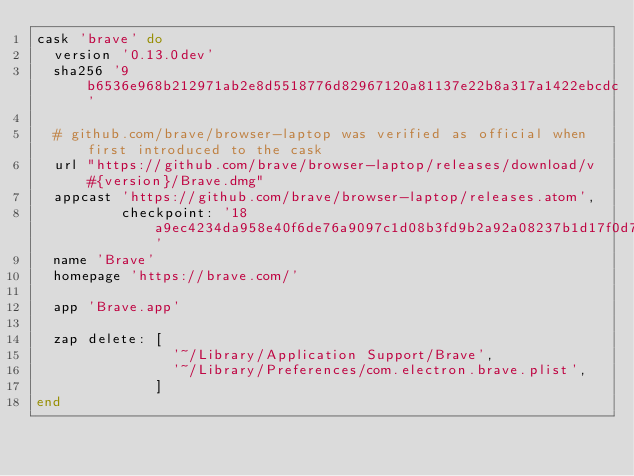<code> <loc_0><loc_0><loc_500><loc_500><_Ruby_>cask 'brave' do
  version '0.13.0dev'
  sha256 '9b6536e968b212971ab2e8d5518776d82967120a81137e22b8a317a1422ebcdc'

  # github.com/brave/browser-laptop was verified as official when first introduced to the cask
  url "https://github.com/brave/browser-laptop/releases/download/v#{version}/Brave.dmg"
  appcast 'https://github.com/brave/browser-laptop/releases.atom',
          checkpoint: '18a9ec4234da958e40f6de76a9097c1d08b3fd9b2a92a08237b1d17f0d7f489a'
  name 'Brave'
  homepage 'https://brave.com/'

  app 'Brave.app'

  zap delete: [
                '~/Library/Application Support/Brave',
                '~/Library/Preferences/com.electron.brave.plist',
              ]
end
</code> 